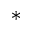Convert formula to latex. <formula><loc_0><loc_0><loc_500><loc_500>^ { * }</formula> 